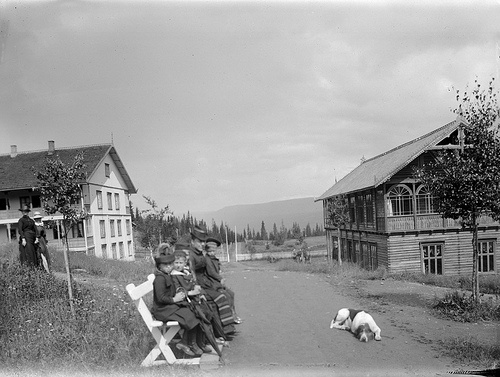Describe the objects in this image and their specific colors. I can see people in lightgray, gray, black, and darkgray tones, bench in lightgray, darkgray, gray, and black tones, people in lightgray, gray, black, and darkgray tones, people in lightgray, gray, black, and darkgray tones, and dog in lightgray, darkgray, gray, and black tones in this image. 